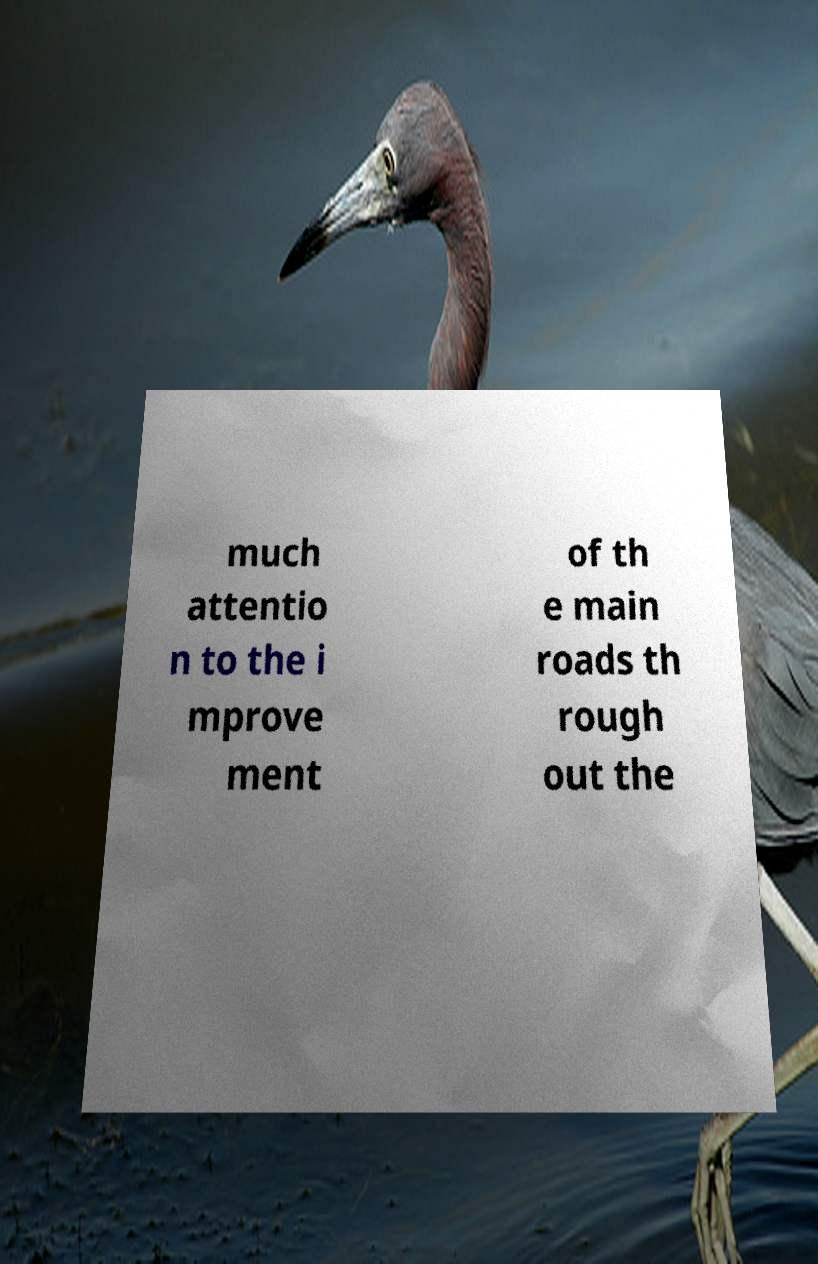Could you assist in decoding the text presented in this image and type it out clearly? much attentio n to the i mprove ment of th e main roads th rough out the 